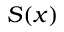Convert formula to latex. <formula><loc_0><loc_0><loc_500><loc_500>S ( x )</formula> 